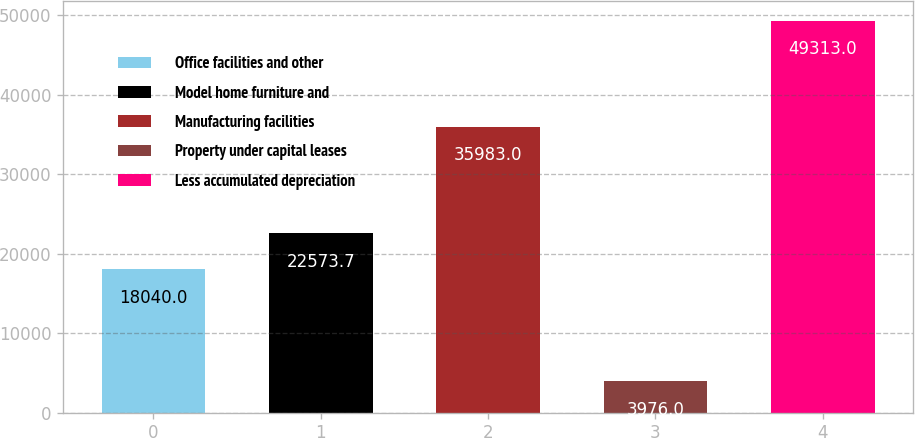Convert chart to OTSL. <chart><loc_0><loc_0><loc_500><loc_500><bar_chart><fcel>Office facilities and other<fcel>Model home furniture and<fcel>Manufacturing facilities<fcel>Property under capital leases<fcel>Less accumulated depreciation<nl><fcel>18040<fcel>22573.7<fcel>35983<fcel>3976<fcel>49313<nl></chart> 